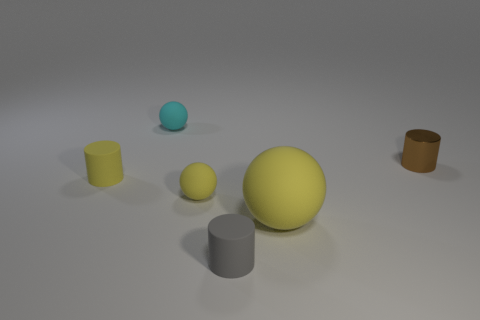Add 4 small cylinders. How many objects exist? 10 Add 1 big yellow things. How many big yellow things are left? 2 Add 3 tiny brown shiny things. How many tiny brown shiny things exist? 4 Subtract 0 green cubes. How many objects are left? 6 Subtract all green spheres. Subtract all small balls. How many objects are left? 4 